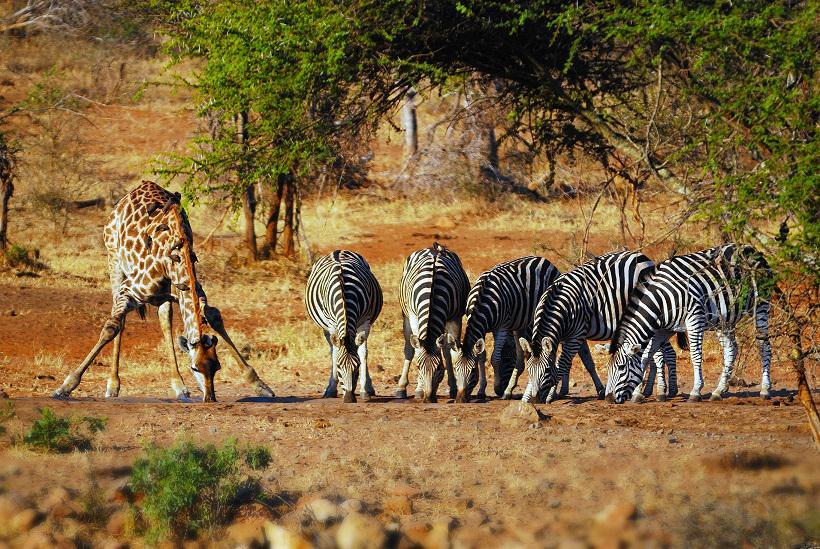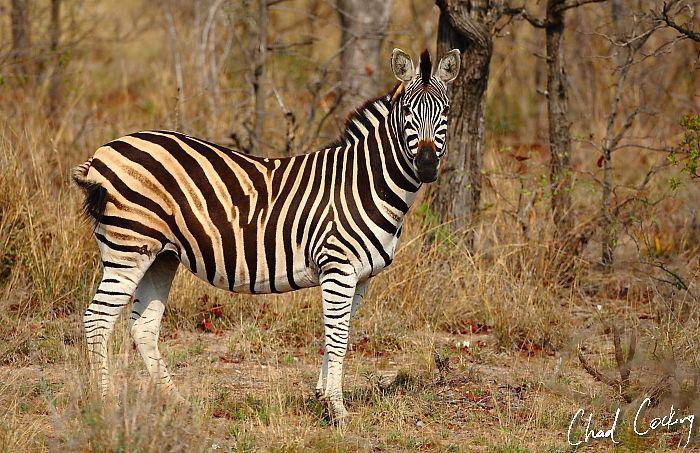The first image is the image on the left, the second image is the image on the right. Considering the images on both sides, is "One image shows zebras standing around grazing, and the other shows zebras that are all walking in one direction." valid? Answer yes or no. No. The first image is the image on the left, the second image is the image on the right. Evaluate the accuracy of this statement regarding the images: "In one of the images the zebras are all walking in the same direction.". Is it true? Answer yes or no. No. 